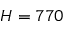<formula> <loc_0><loc_0><loc_500><loc_500>H = 7 7 0</formula> 